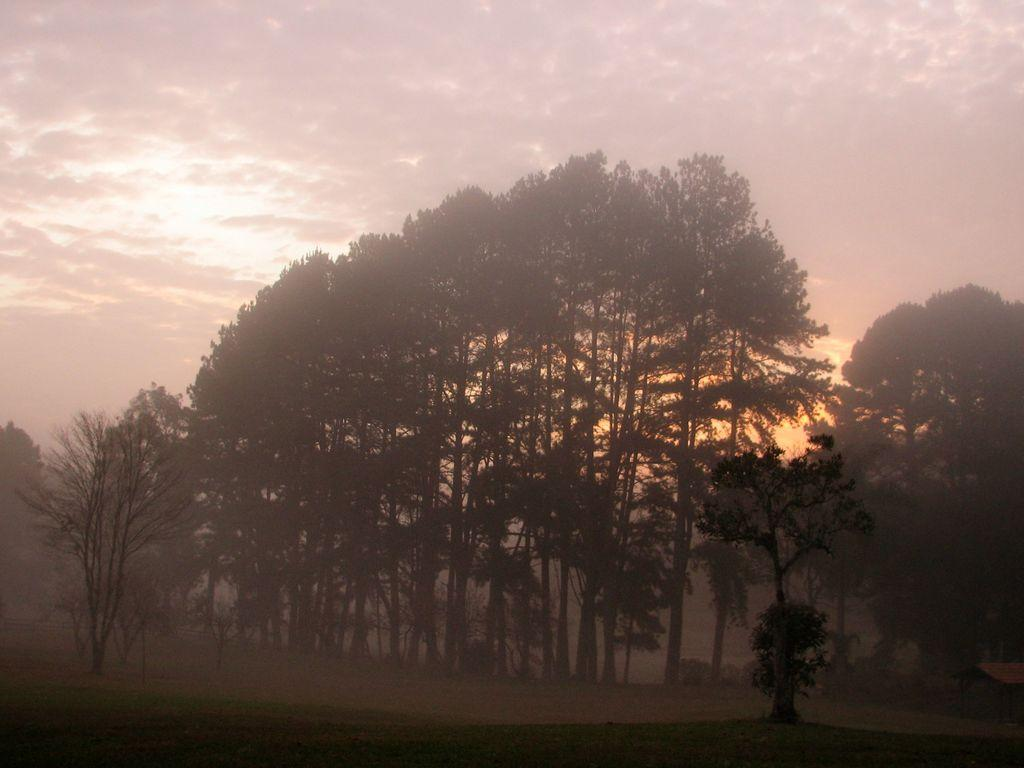What is visible at the bottom of the image? The ground is visible in the image. What type of vegetation can be seen on the ground in the image? There are trees on the ground in the image. What is visible in the distance in the image? The sky and water are visible in the background of the image. How is the water being used to measure the distance between the trees in the image? There is no indication in the image that the water is being used to measure anything, nor is there any reference to measuring distances between trees. 